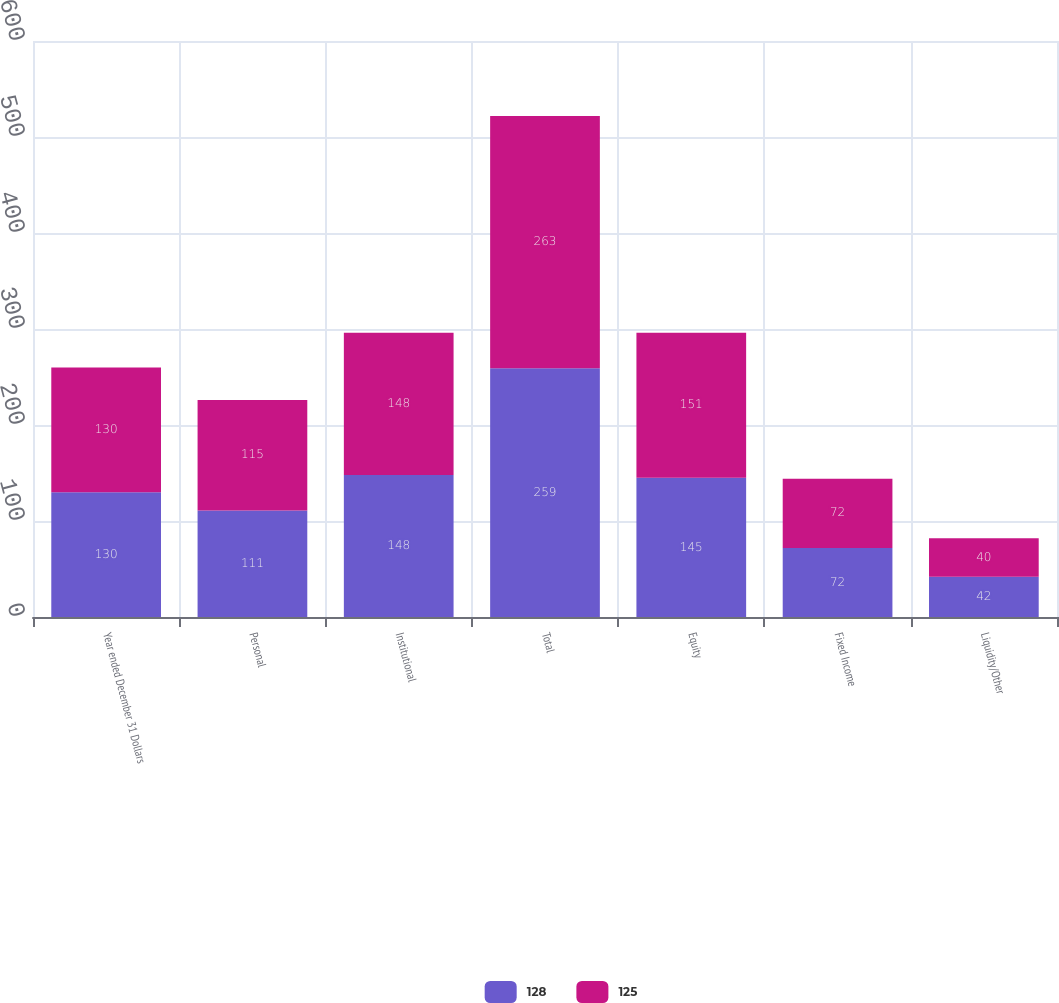Convert chart to OTSL. <chart><loc_0><loc_0><loc_500><loc_500><stacked_bar_chart><ecel><fcel>Year ended December 31 Dollars<fcel>Personal<fcel>Institutional<fcel>Total<fcel>Equity<fcel>Fixed Income<fcel>Liquidity/Other<nl><fcel>128<fcel>130<fcel>111<fcel>148<fcel>259<fcel>145<fcel>72<fcel>42<nl><fcel>125<fcel>130<fcel>115<fcel>148<fcel>263<fcel>151<fcel>72<fcel>40<nl></chart> 